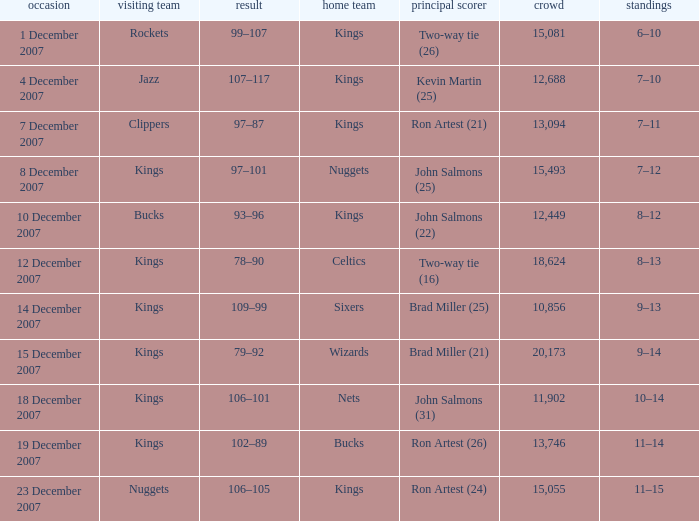What was the record of the game where the Rockets were the visiting team? 6–10. 